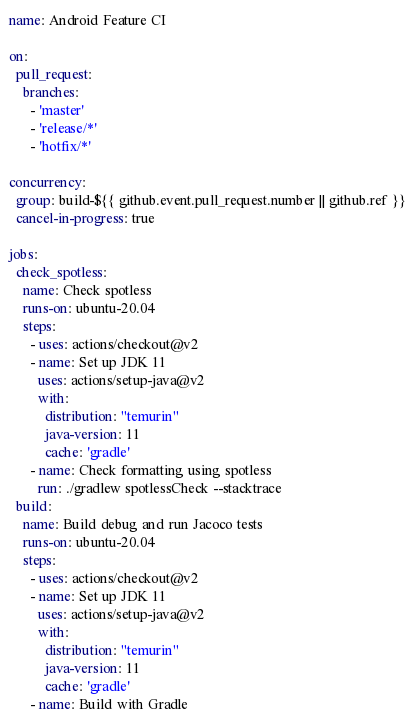Convert code to text. <code><loc_0><loc_0><loc_500><loc_500><_YAML_>name: Android Feature CI

on:
  pull_request:
    branches:
      - 'master'
      - 'release/*'
      - 'hotfix/*'

concurrency:
  group: build-${{ github.event.pull_request.number || github.ref }}
  cancel-in-progress: true

jobs:
  check_spotless:
    name: Check spotless
    runs-on: ubuntu-20.04
    steps:
      - uses: actions/checkout@v2
      - name: Set up JDK 11
        uses: actions/setup-java@v2
        with:
          distribution: "temurin"
          java-version: 11
          cache: 'gradle'
      - name: Check formatting using spotless
        run: ./gradlew spotlessCheck --stacktrace
  build:
    name: Build debug and run Jacoco tests
    runs-on: ubuntu-20.04
    steps:
      - uses: actions/checkout@v2
      - name: Set up JDK 11
        uses: actions/setup-java@v2
        with:
          distribution: "temurin"
          java-version: 11
          cache: 'gradle'
      - name: Build with Gradle</code> 